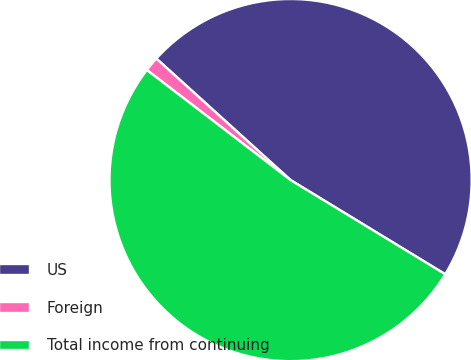Convert chart. <chart><loc_0><loc_0><loc_500><loc_500><pie_chart><fcel>US<fcel>Foreign<fcel>Total income from continuing<nl><fcel>47.0%<fcel>1.31%<fcel>51.7%<nl></chart> 